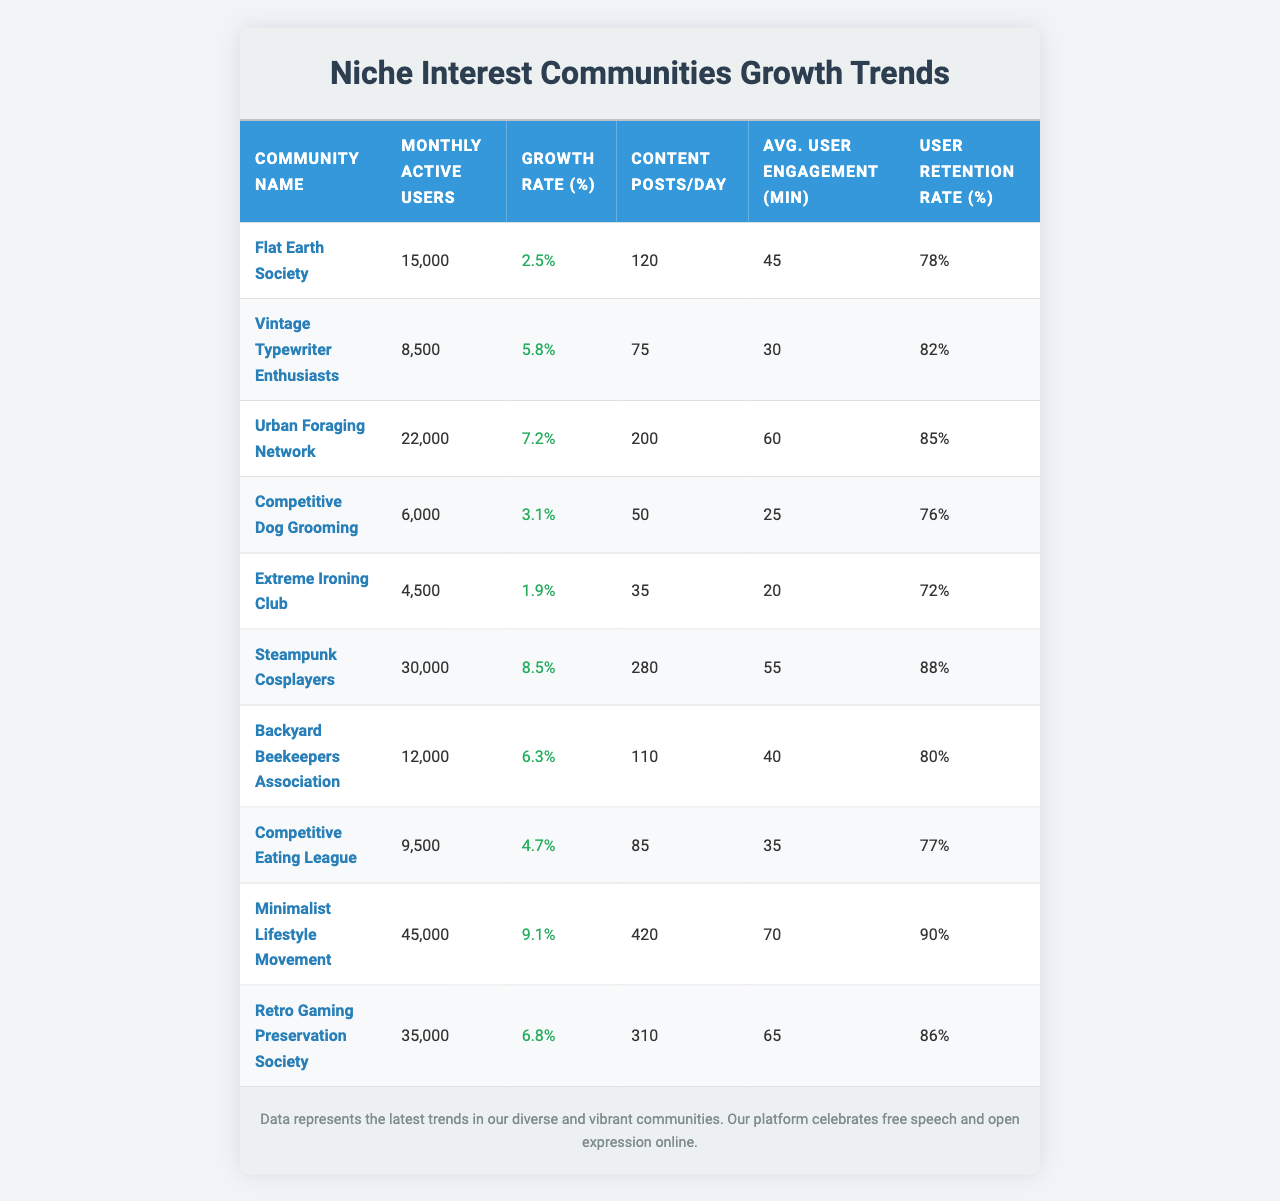What is the community with the highest number of monthly active users? By looking at the "Monthly Active Users" column, the community with the highest value is the "Minimalist Lifestyle Movement" with 45,000 active users.
Answer: Minimalist Lifestyle Movement Which community has the lowest monthly active users? The "Extreme Ironing Club" has the lowest value in the "Monthly Active Users" column with only 4,500 users.
Answer: Extreme Ironing Club What is the average growth rate of all communities? To find the average growth rate, sum all the values in the "Growth Rate (%)" column (2.5 + 5.8 + 7.2 + 3.1 + 1.9 + 8.5 + 6.3 + 4.7 + 9.1 + 6.8) = 54.9, then divide by the number of communities (54.9 / 10) = 5.49.
Answer: 5.49% Which community has the highest user retention rate? Looking at the "User Retention Rate (%)" column, "Minimalist Lifestyle Movement" has the highest retention rate of 90%.
Answer: Minimalist Lifestyle Movement Is the "Competitive Dog Grooming" community growing faster than the "Urban Foraging Network"? The growth rate for "Competitive Dog Grooming" is 3.1% and for "Urban Foraging Network" is 7.2%. Since 3.1% is less than 7.2%, "Competitive Dog Grooming" is not growing faster.
Answer: No What is the difference in content posts per day between the "Steampunk Cosplayers" and "Flat Earth Society"? The "Steampunk Cosplayers" make 280 posts per day while the "Flat Earth Society" makes 120 posts. The difference is 280 - 120 = 160 posts per day.
Answer: 160 posts Which community has the highest engagement time per user? The "Minimalist Lifestyle Movement" has the highest average user engagement with 70 minutes.
Answer: Minimalist Lifestyle Movement What is the total number of monthly active users for all communities combined? To find the total, sum the "Monthly Active Users" values (15000 + 8500 + 22000 + 6000 + 4500 + 30000 + 12000 + 9500 + 45000 + 35000) = 157,500.
Answer: 157,500 Which community has the lowest user retention rate? The "Extreme Ironing Club" has the lowest user retention rate of 72%.
Answer: Extreme Ironing Club Is the average engagement time for the "Urban Foraging Network" higher than the overall average? The "Urban Foraging Network" has an engagement time of 60 minutes. The overall average can be calculated as (45 + 30 + 60 + 25 + 20 + 55 + 40 + 35 + 70 + 65) = 40.5 minutes. Since 60 > 40.5, it is higher.
Answer: Yes Which communities have a growth rate greater than 6% and also have more than 20,000 monthly active users? Look at the growth rates: "Urban Foraging Network" (7.2%), "Steampunk Cosplayers" (8.5%), "Minimalist Lifestyle Movement" (9.1%), "Retro Gaming Preservation Society" (6.8%). The qualifying communities with more than 20,000 users are "Urban Foraging Network" and "Minimalist Lifestyle Movement."
Answer: Urban Foraging Network, Minimalist Lifestyle Movement 